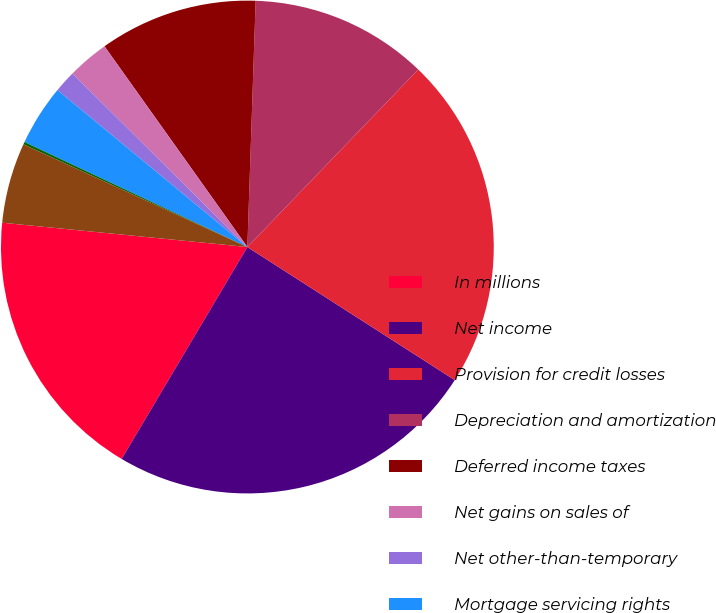Convert chart. <chart><loc_0><loc_0><loc_500><loc_500><pie_chart><fcel>In millions<fcel>Net income<fcel>Provision for credit losses<fcel>Depreciation and amortization<fcel>Deferred income taxes<fcel>Net gains on sales of<fcel>Net other-than-temporary<fcel>Mortgage servicing rights<fcel>Undistributed earnings of<fcel>Trading securities and other<nl><fcel>18.05%<fcel>24.44%<fcel>21.88%<fcel>11.66%<fcel>10.38%<fcel>2.72%<fcel>1.44%<fcel>3.99%<fcel>0.16%<fcel>5.27%<nl></chart> 